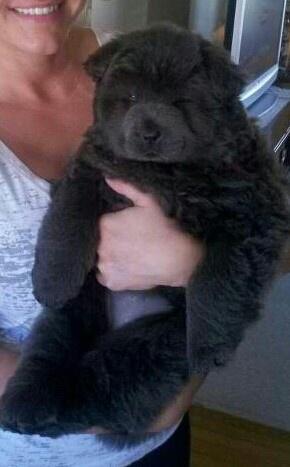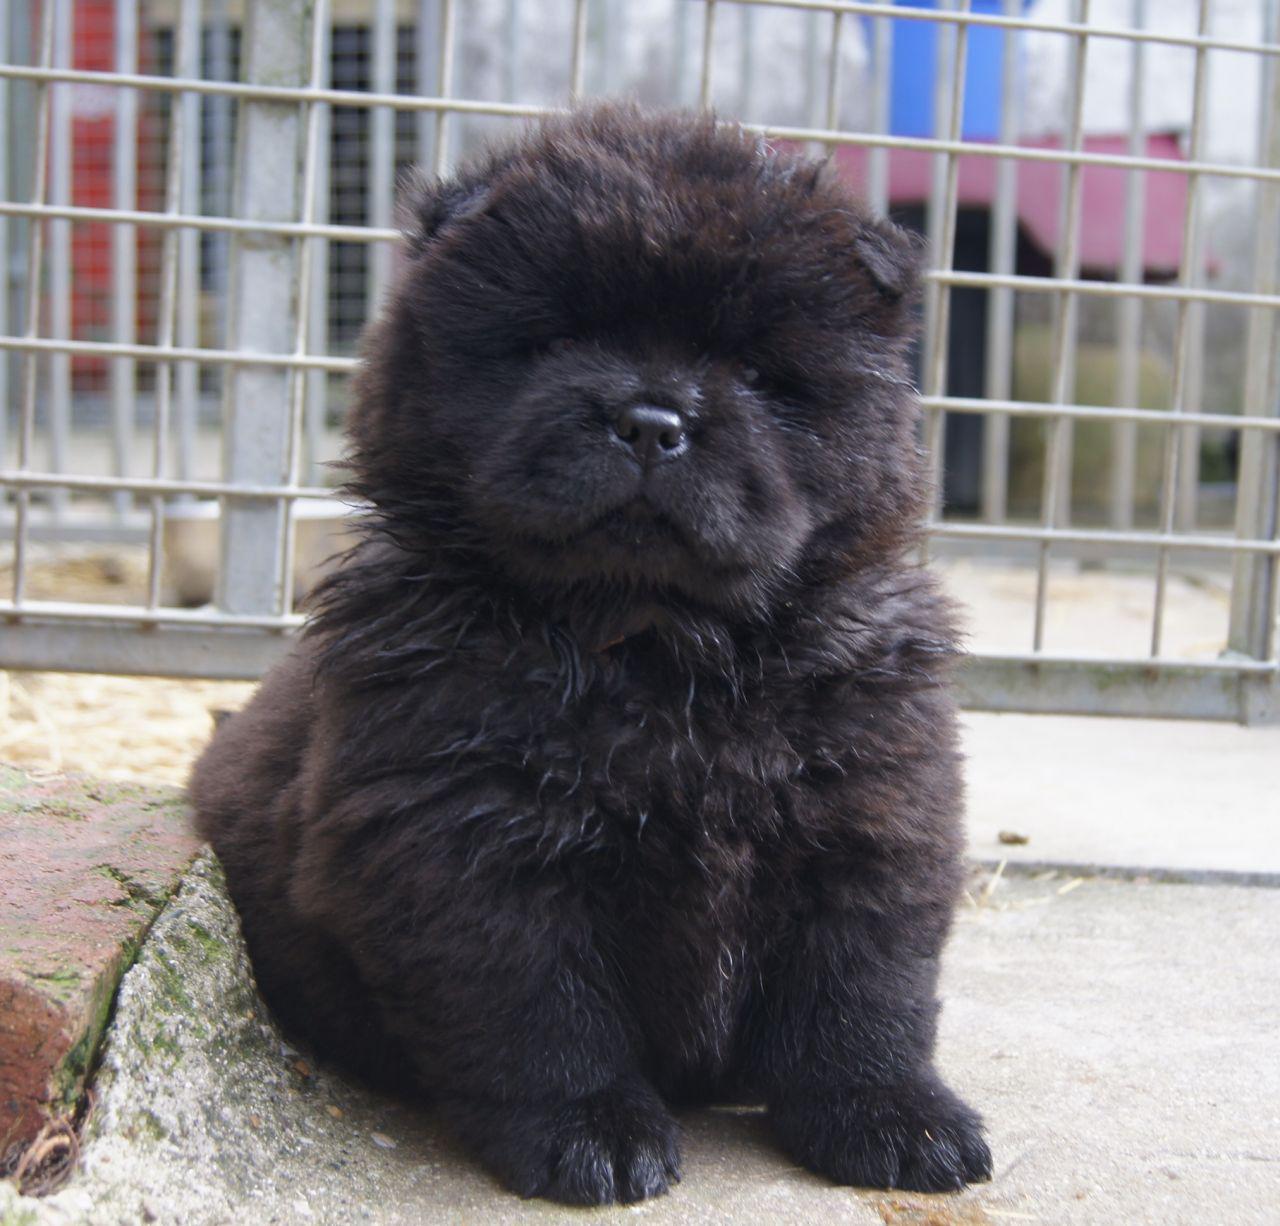The first image is the image on the left, the second image is the image on the right. For the images displayed, is the sentence "A person holds up a chow puppy in the left image, and the right image features a black chow puppy in front of a metal fence-like barrier." factually correct? Answer yes or no. Yes. The first image is the image on the left, the second image is the image on the right. Considering the images on both sides, is "One image in the pair shows a single black dog and the other shows a single tan dog." valid? Answer yes or no. No. 